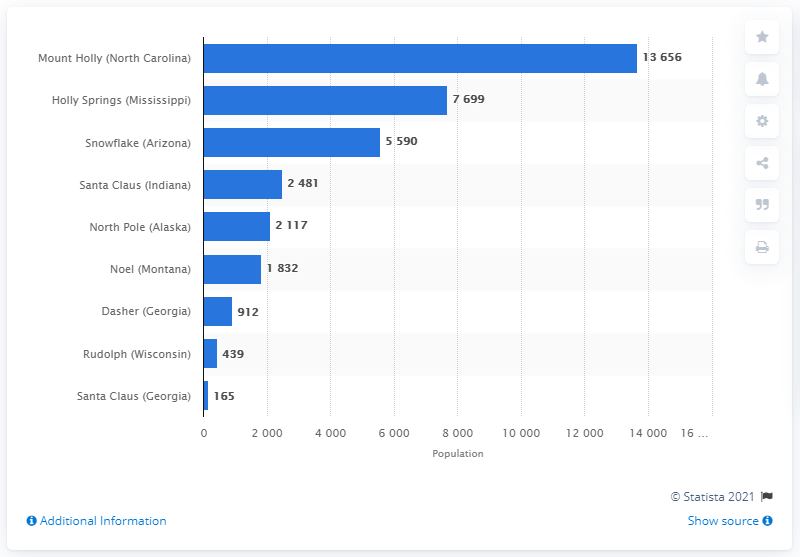Outline some significant characteristics in this image. In 2010, the town of the same name in Georgia was home to 165 people. 